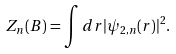Convert formula to latex. <formula><loc_0><loc_0><loc_500><loc_500>Z _ { n } ( B ) = \int d r | \psi _ { 2 , n } ( r ) | ^ { 2 } .</formula> 